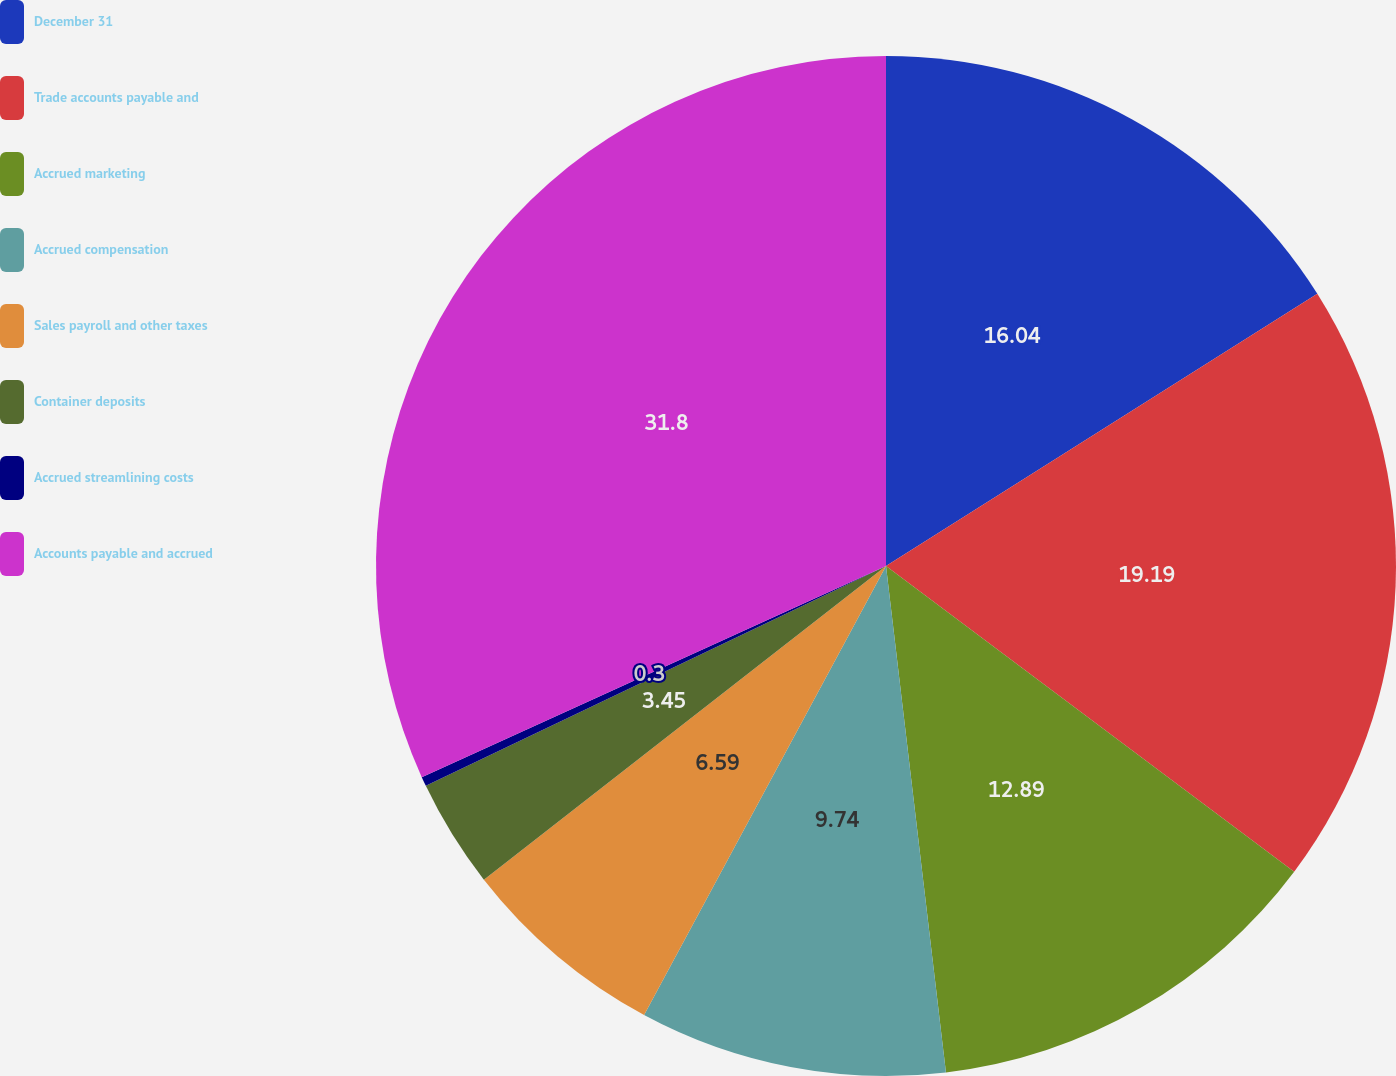<chart> <loc_0><loc_0><loc_500><loc_500><pie_chart><fcel>December 31<fcel>Trade accounts payable and<fcel>Accrued marketing<fcel>Accrued compensation<fcel>Sales payroll and other taxes<fcel>Container deposits<fcel>Accrued streamlining costs<fcel>Accounts payable and accrued<nl><fcel>16.04%<fcel>19.19%<fcel>12.89%<fcel>9.74%<fcel>6.59%<fcel>3.45%<fcel>0.3%<fcel>31.79%<nl></chart> 